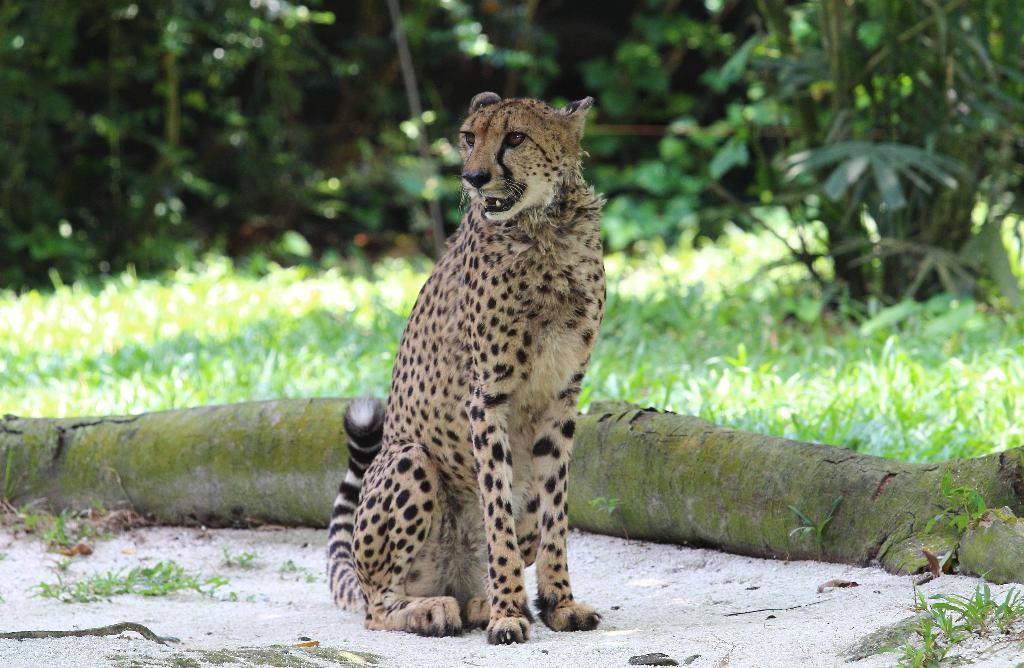Describe this image in one or two sentences. In the image we can see there is a leopard sitting on the ground and there is tree log on the ground. Behind there is ground covered with grass and there are trees. Background of the image is little blurred. 